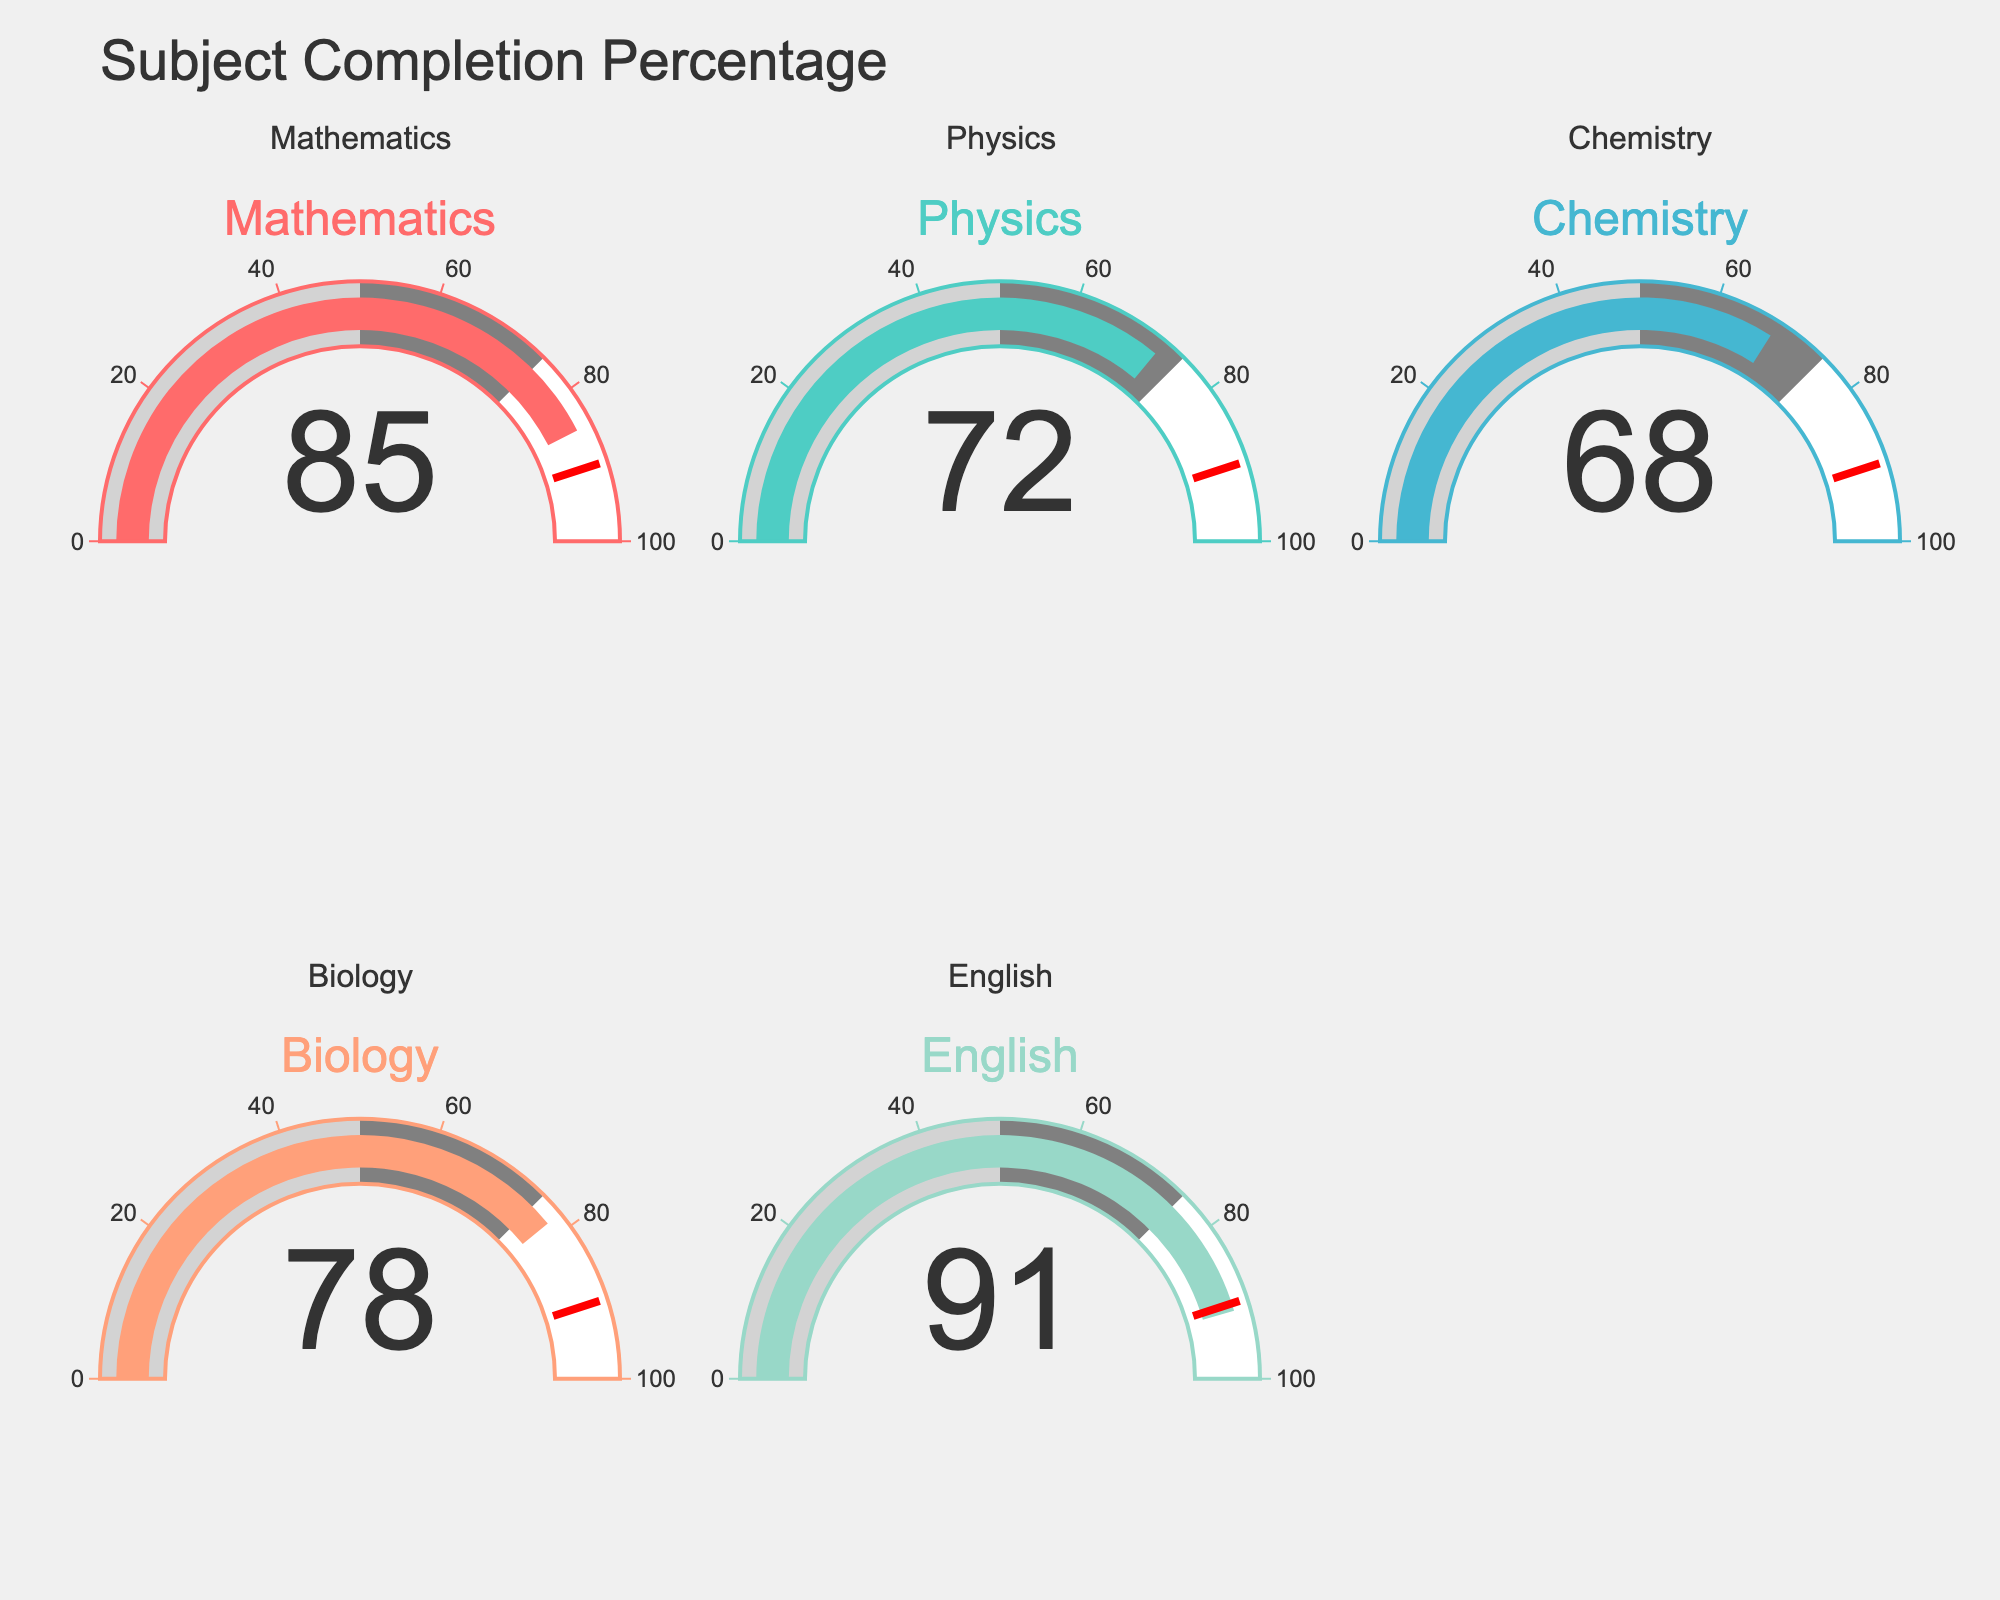What's the completion percentage for Mathematics? To find the completion percentage for Mathematics, look at the gauge labeled "Mathematics". The number displayed on the gauge is the completion percentage.
Answer: 85% Which subject has the highest completion percentage? Compare the numbers on all the gauges. The subject with the highest number is the one with the highest completion percentage. The gauge labeled "English" shows the highest percentage.
Answer: English What is the average completion percentage of all subjects? Add the completion percentages of all subjects: 85 (Mathematics) + 72 (Physics) + 68 (Chemistry) + 78 (Biology) + 91 (English) = 394. Then, divide by the number of subjects (5): 394 / 5 = 78.8
Answer: 78.8% Which subject has a lower completion percentage, Physics or Chemistry? Compare the numbers on the gauges for Physics and Chemistry. Physics shows 72% and Chemistry shows 68%.
Answer: Chemistry How many subjects have a completion percentage below 75%? Review the numbers on all gauges: Physics (72%), Chemistry (68%), and Biology (78%), and determine how many are below 75%.
Answer: 2 What is the difference in completion percentage between Biology and Chemistry? Subtract the completion percentage for Chemistry from Biology: 78 (Biology) - 68 (Chemistry) = 10
Answer: 10% Is the completion percentage for Mathematics above the threshold of 90%? Check the number on the gauge for Mathematics and compare it to 90%. Since Mathematics shows 85%, it is below the threshold.
Answer: No Which subjects have at least 80% completion percentage? Identify the gauges with numbers 80 or above: Mathematics (85%) and English (91%)
Answer: Mathematics, English Which subject has the lowest completion percentage? Compare the numbers on all gauges. The subject with the lowest number is Chemistry with 68%.
Answer: Chemistry What is the median completion percentage of the subjects? List all completion percentages in ascending order: 68, 72, 78, 85, 91. The median is the middle value, which is 78.
Answer: 78% 